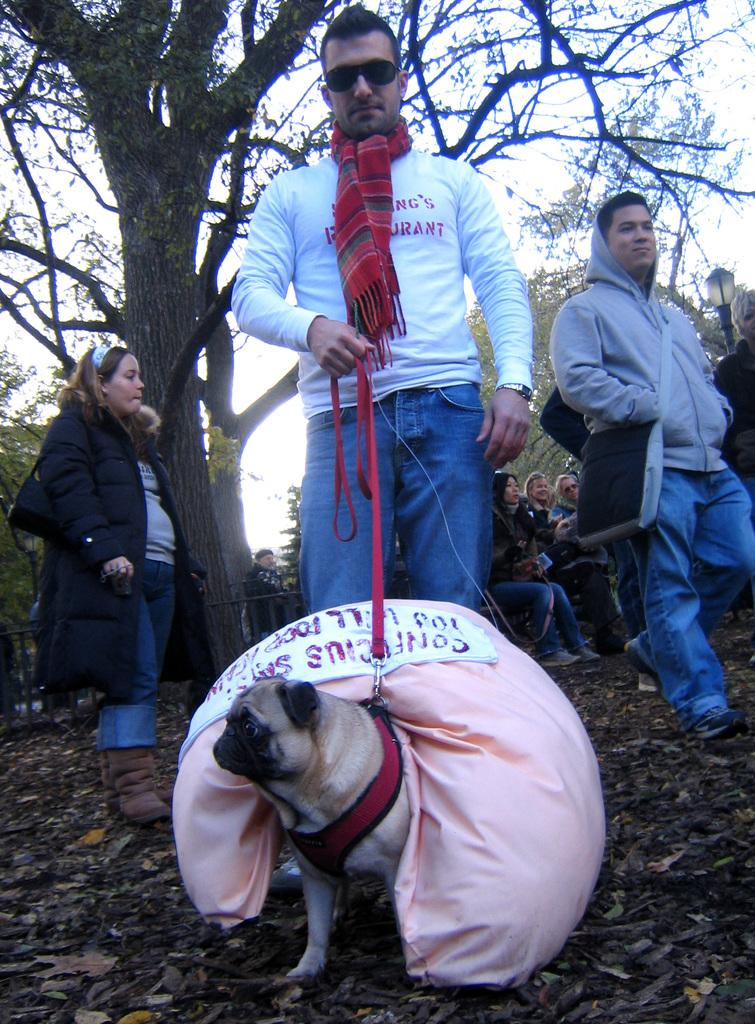What is the man in the image holding? The man is holding a belt tied to a dog. What is on the dog in the image? There is a bag on the dog. What can be seen in the background of the image? There are people and trees in the background of the image, and the sky is also visible. How many feathers can be seen on the dog in the image? There are no feathers visible on the dog in the image. What level of difficulty is the dog attempting in the image? The image does not depict a specific level of difficulty for the dog; it simply shows a man holding a belt tied to the dog. 